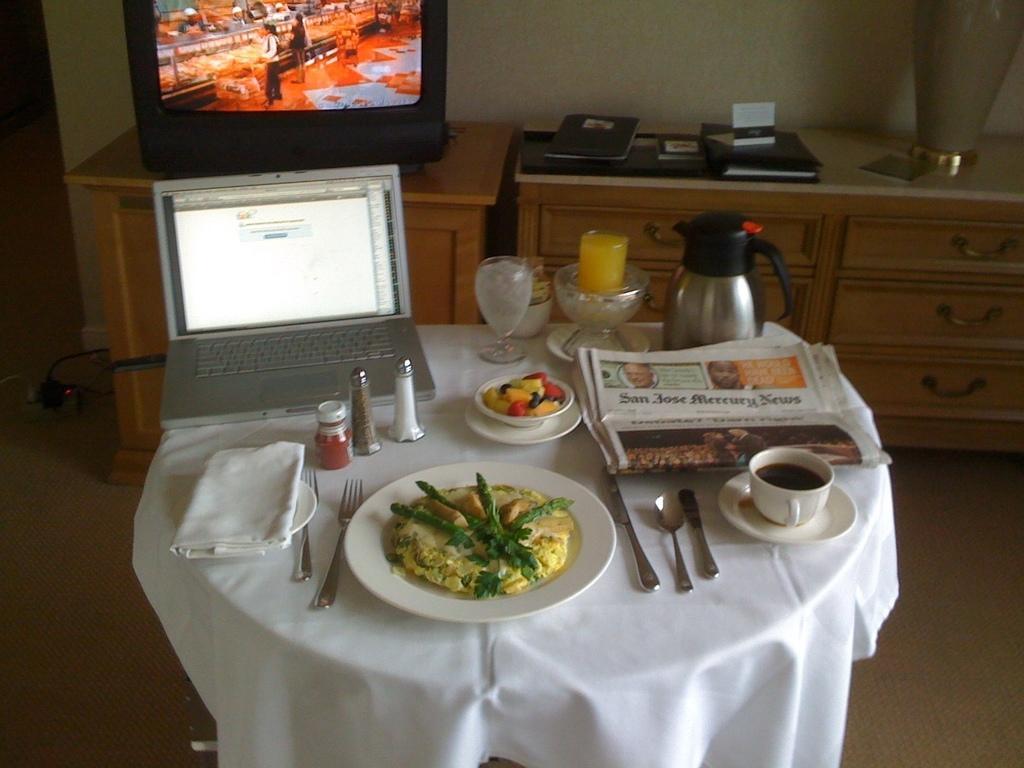How would you summarize this image in a sentence or two? In this image i can see a plate, spoons, cup, paper laptop at the back ground i can see a television, cupboard and a wall. 